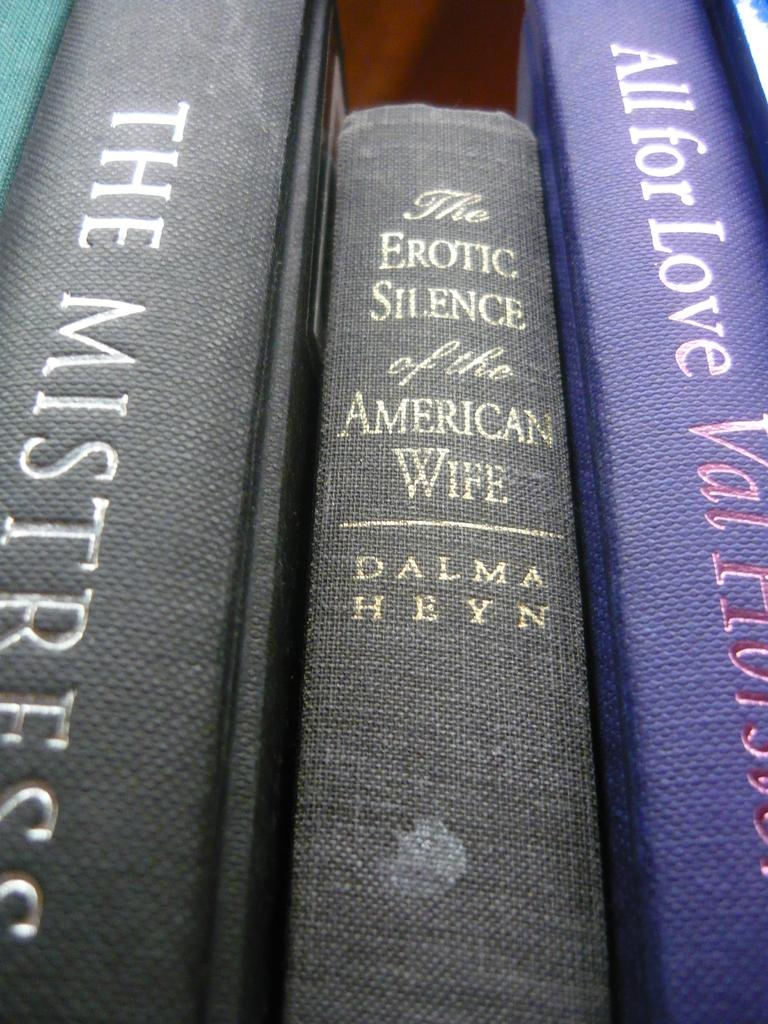<image>
Summarize the visual content of the image. Dalma Heyn wrote "The Erotic Silence of the American Wife." 